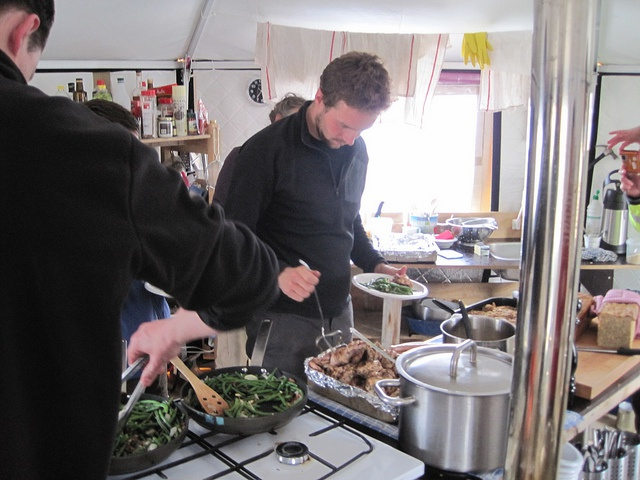Describe the objects in this image and their specific colors. I can see people in black, brown, gray, and darkgray tones, people in black, gray, and salmon tones, oven in black, darkgray, and gray tones, people in black, gray, and darkgray tones, and spoon in black, tan, and gray tones in this image. 